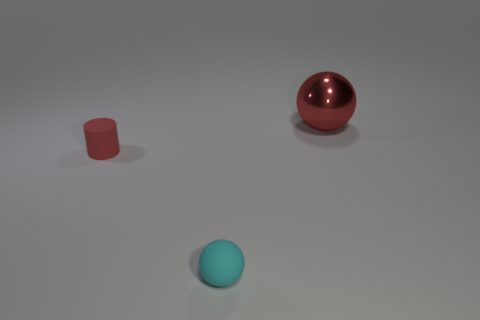Add 2 tiny spheres. How many objects exist? 5 Subtract all spheres. How many objects are left? 1 Subtract 0 blue cubes. How many objects are left? 3 Subtract all tiny cyan matte objects. Subtract all red spheres. How many objects are left? 1 Add 2 large metal objects. How many large metal objects are left? 3 Add 2 large balls. How many large balls exist? 3 